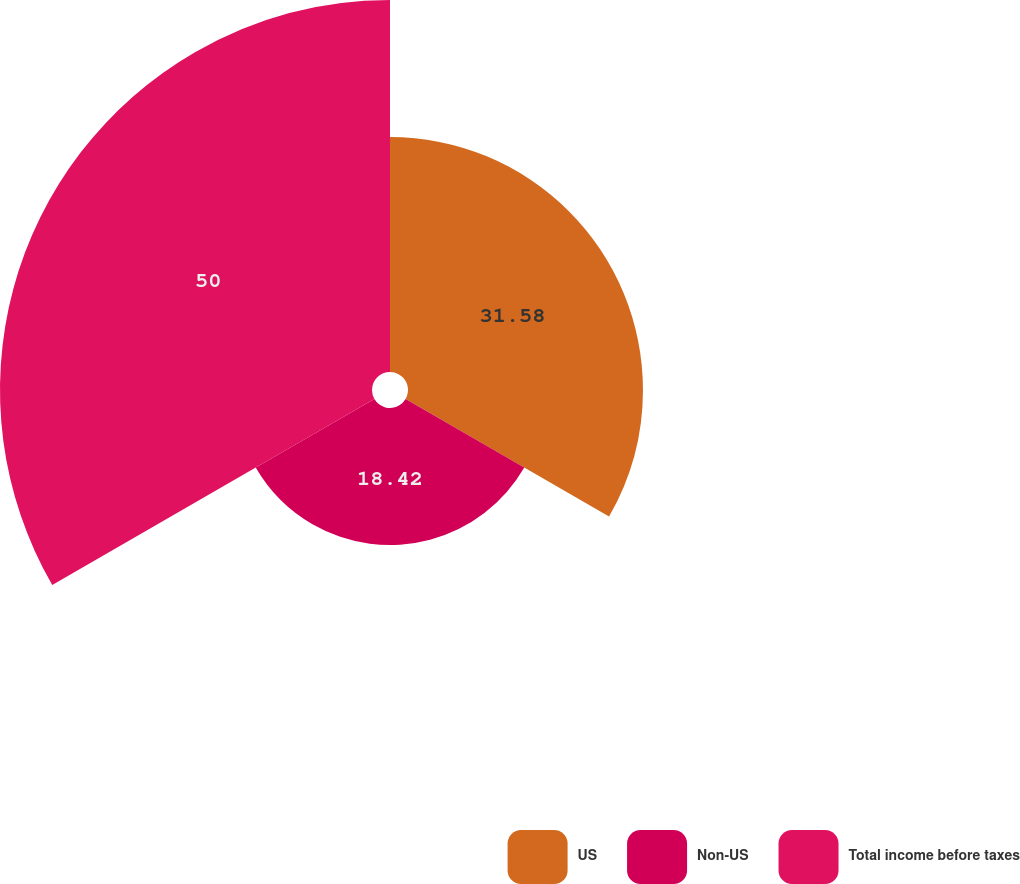<chart> <loc_0><loc_0><loc_500><loc_500><pie_chart><fcel>US<fcel>Non-US<fcel>Total income before taxes<nl><fcel>31.58%<fcel>18.42%<fcel>50.0%<nl></chart> 